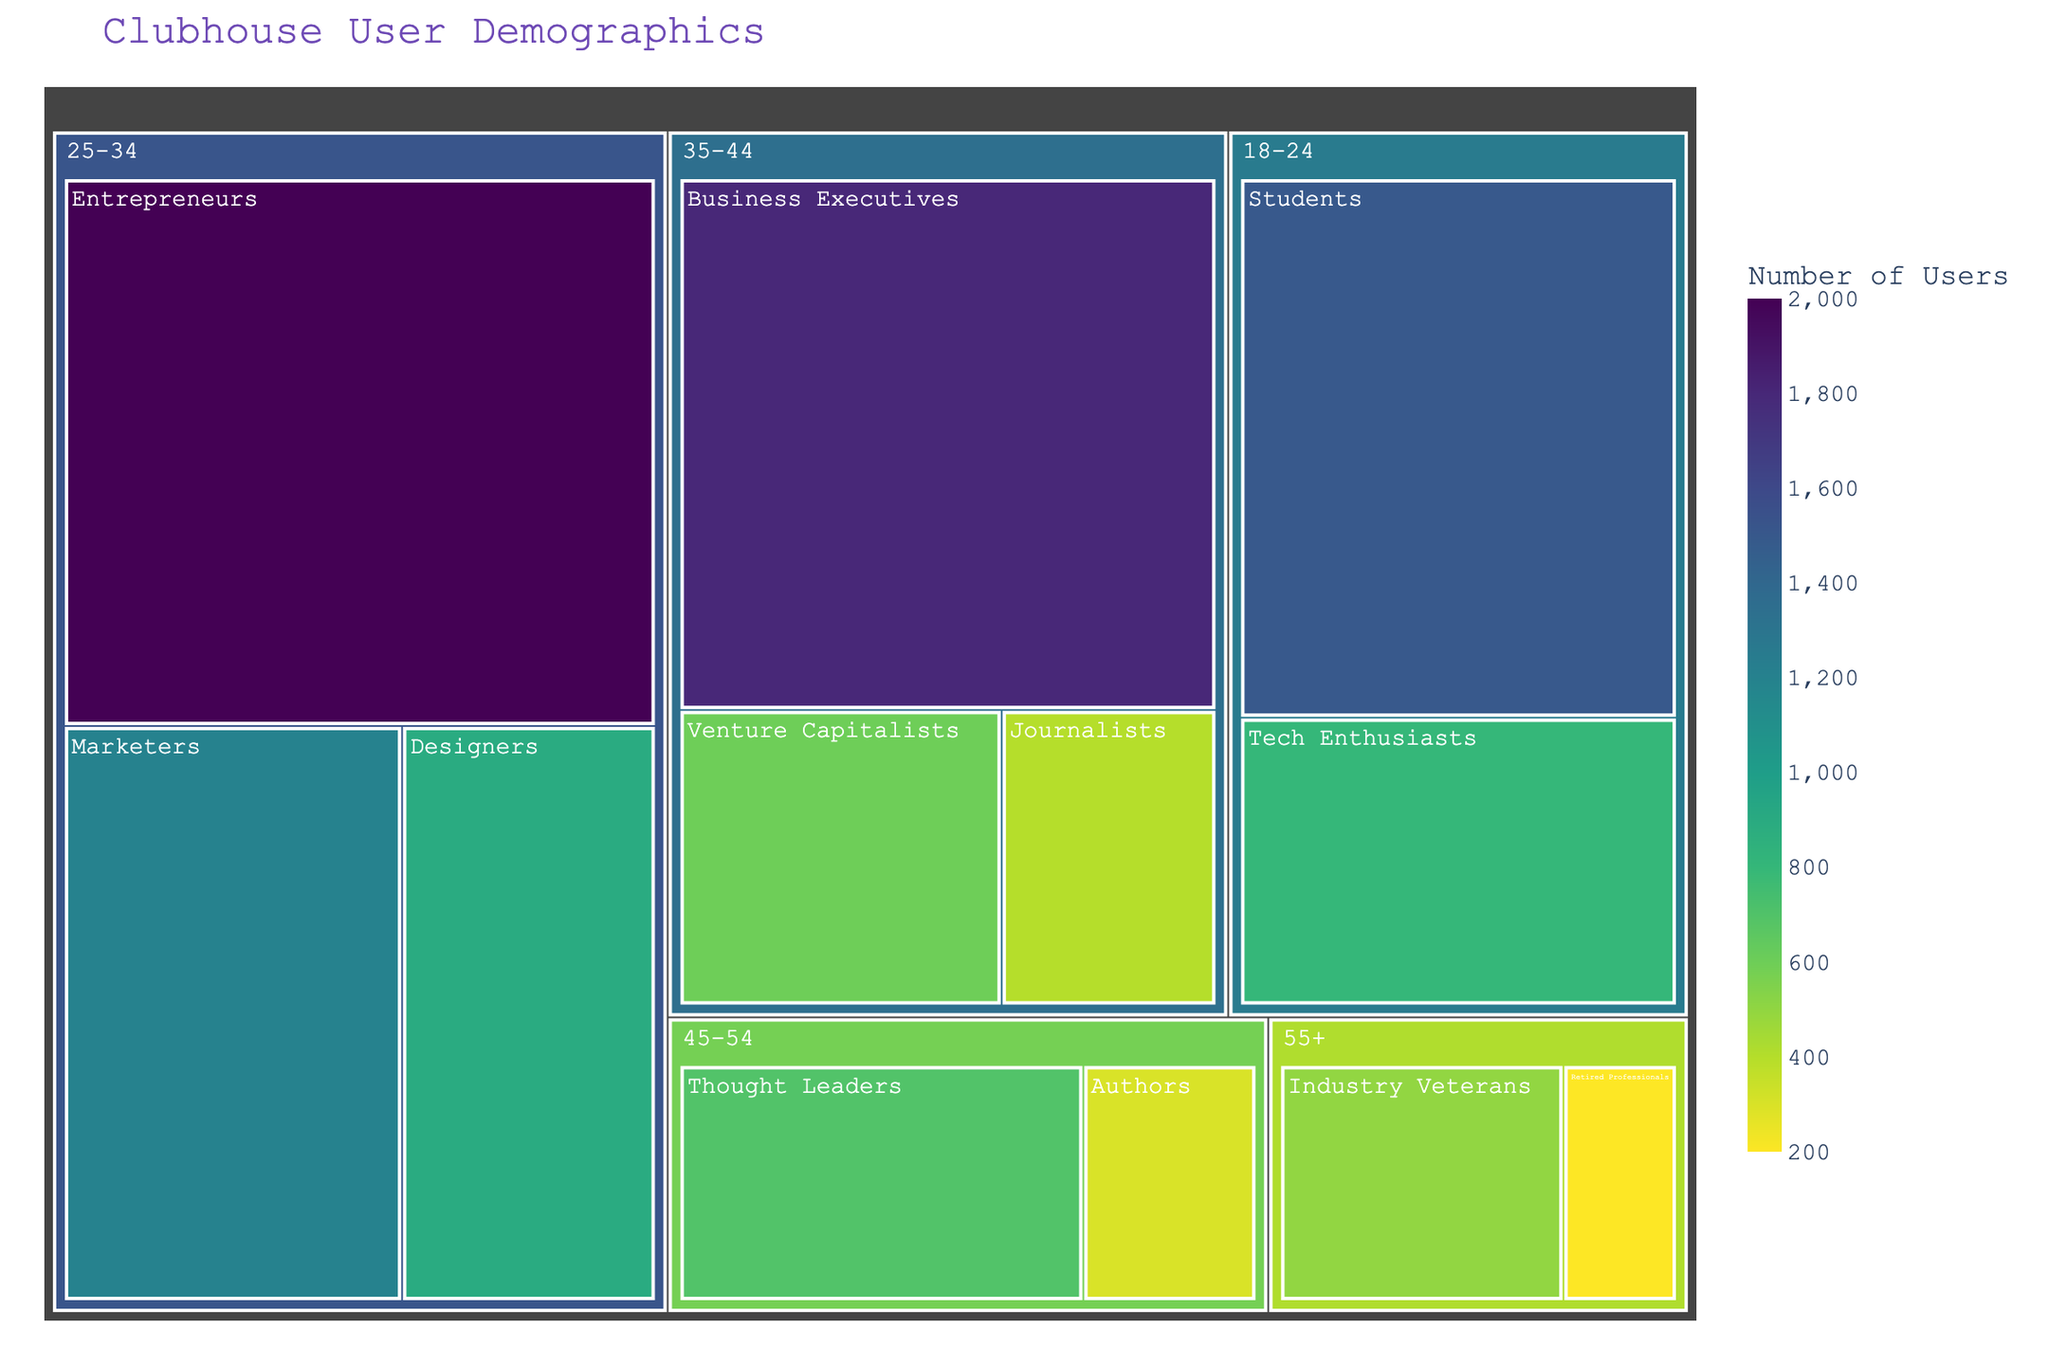What's the title of the figure? The title is visually prominent at the top of the figure and is styled in a larger font with a particular color. The title helps set the context of the data being visualized.
Answer: Clubhouse User Demographics Which profession has the highest number of users in the '25-34' age group? The '25-34' age group has multiple professions, each represented with a different size rectangle. The size of the rectangle reflects the number of users. By comparing rectangles, the largest one belongs to "Entrepreneurs".
Answer: Entrepreneurs What is the total number of users in the '35-44' age group? By summing the users in all professions within the '35-44' age group: Business Executives (1800), Venture Capitalists (600), Journalists (400), the total is 1800 + 600 + 400.
Answer: 2800 Which age group has the largest rectangular area in the treemap? The largest rectangular area indicates the highest total number of users. By comparing the sizes, the '25-34' age group covers the most area.
Answer: 25-34 What is the difference in the number of users between Business Executives in the '35-44' age group and Tech Enthusiasts in the '18-24' age group? Subtract the users of Tech Enthusiasts from the users of Business Executives: 1800 - 800
Answer: 1000 What color pattern is used for representing the number of users, and what does it signify? The treemap uses a sequential color scale from dark to light shades, where darker colors represent a higher number of users and lighter colors represent fewer users.
Answer: Darker colors for more users, lighter for fewer How many professions are represented in the '45-54' age group? The '45-54' age group has rectangles for each profession, the total count of these rectangles is 2 (Thought Leaders and Authors).
Answer: 2 Which profession among 'Designers' and 'Students' has more users, and in which age group are they found? Designers are found in the '25-34' age group with 900 users while Students are in the '18-24' age group with 1500 users. Comparing the numbers, Students have more users.
Answer: Students, 18-24 What is the average number of users for professions in the '55+' age group? The '55+' age group has 2 professions: Industry Veterans (500) and Retired Professionals (200). The average is calculated as (500 + 200)/2.
Answer: 350 